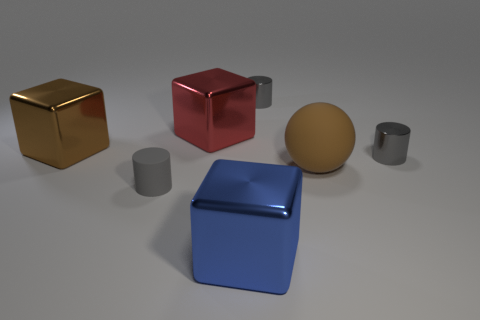Subtract all gray cylinders. How many were subtracted if there are1gray cylinders left? 2 Add 1 large brown metal cylinders. How many objects exist? 8 Subtract all blocks. How many objects are left? 4 Add 4 spheres. How many spheres are left? 5 Add 1 big green balls. How many big green balls exist? 1 Subtract 0 purple cylinders. How many objects are left? 7 Subtract all balls. Subtract all cylinders. How many objects are left? 3 